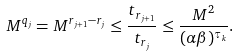Convert formula to latex. <formula><loc_0><loc_0><loc_500><loc_500>M ^ { q _ { j } } = M ^ { r _ { j + 1 } - r _ { j } } \leq \frac { t _ { r _ { j + 1 } } } { t _ { r _ { j } } } \leq \frac { M ^ { 2 } } { ( \alpha \beta ) ^ { \tau _ { k } } } .</formula> 